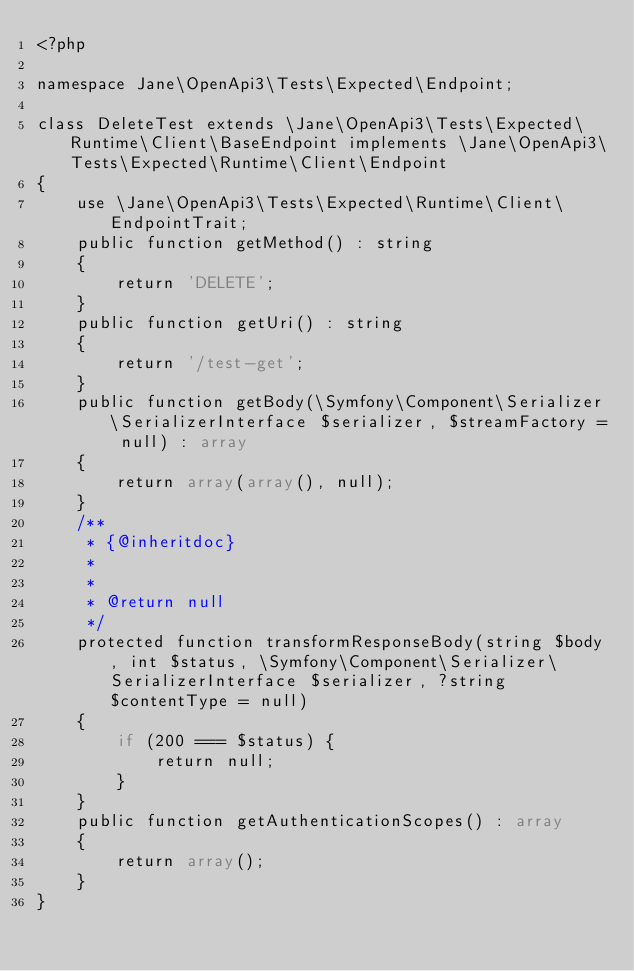Convert code to text. <code><loc_0><loc_0><loc_500><loc_500><_PHP_><?php

namespace Jane\OpenApi3\Tests\Expected\Endpoint;

class DeleteTest extends \Jane\OpenApi3\Tests\Expected\Runtime\Client\BaseEndpoint implements \Jane\OpenApi3\Tests\Expected\Runtime\Client\Endpoint
{
    use \Jane\OpenApi3\Tests\Expected\Runtime\Client\EndpointTrait;
    public function getMethod() : string
    {
        return 'DELETE';
    }
    public function getUri() : string
    {
        return '/test-get';
    }
    public function getBody(\Symfony\Component\Serializer\SerializerInterface $serializer, $streamFactory = null) : array
    {
        return array(array(), null);
    }
    /**
     * {@inheritdoc}
     *
     *
     * @return null
     */
    protected function transformResponseBody(string $body, int $status, \Symfony\Component\Serializer\SerializerInterface $serializer, ?string $contentType = null)
    {
        if (200 === $status) {
            return null;
        }
    }
    public function getAuthenticationScopes() : array
    {
        return array();
    }
}</code> 